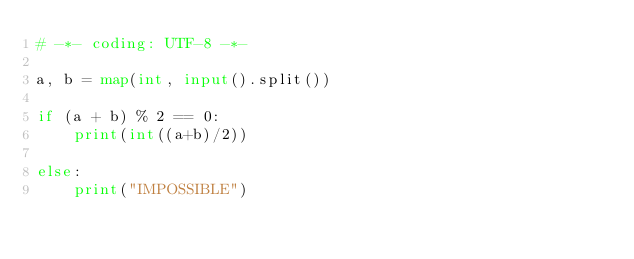<code> <loc_0><loc_0><loc_500><loc_500><_Python_># -*- coding: UTF-8 -*-

a, b = map(int, input().split())

if (a + b) % 2 == 0:
    print(int((a+b)/2))

else:
    print("IMPOSSIBLE")
</code> 